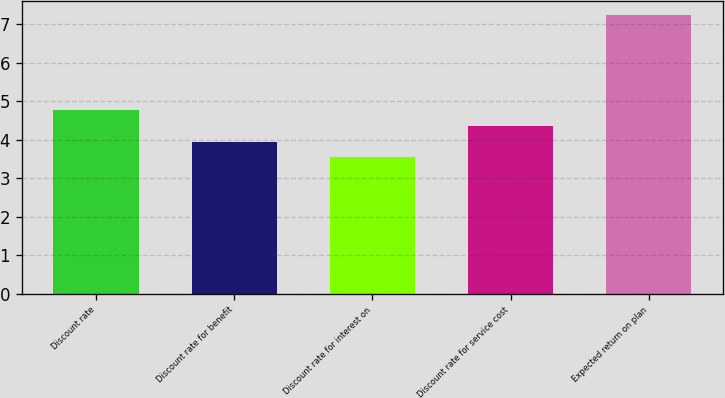Convert chart to OTSL. <chart><loc_0><loc_0><loc_500><loc_500><bar_chart><fcel>Discount rate<fcel>Discount rate for benefit<fcel>Discount rate for interest on<fcel>Discount rate for service cost<fcel>Expected return on plan<nl><fcel>4.77<fcel>3.95<fcel>3.54<fcel>4.36<fcel>7.25<nl></chart> 